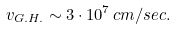<formula> <loc_0><loc_0><loc_500><loc_500>v _ { G . H . } \sim 3 \cdot 1 0 ^ { 7 } \, c m / s e c .</formula> 